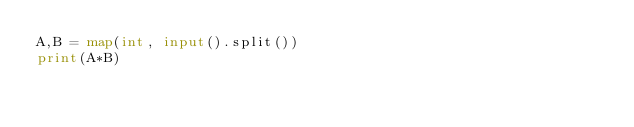Convert code to text. <code><loc_0><loc_0><loc_500><loc_500><_Python_>A,B = map(int, input().split())
print(A*B)</code> 